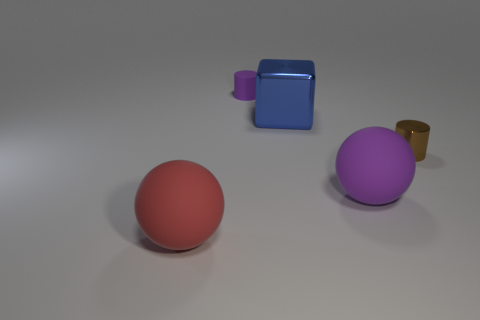Does the small purple rubber object have the same shape as the tiny brown metallic object?
Give a very brief answer. Yes. The matte thing that is both in front of the blue metallic object and to the left of the purple rubber sphere is what color?
Provide a succinct answer. Red. There is a purple thing in front of the tiny brown object; is its size the same as the matte sphere that is to the left of the big cube?
Ensure brevity in your answer.  Yes. How many things are rubber spheres that are on the left side of the purple cylinder or green rubber cylinders?
Give a very brief answer. 1. What material is the purple sphere?
Give a very brief answer. Rubber. Does the red object have the same size as the block?
Provide a succinct answer. Yes. What number of balls are either small brown shiny things or blue metallic things?
Provide a short and direct response. 0. What color is the shiny object on the right side of the matte sphere that is to the right of the block?
Keep it short and to the point. Brown. Are there fewer tiny purple rubber objects in front of the large purple object than big matte objects that are in front of the small brown cylinder?
Your answer should be very brief. Yes. Do the purple sphere and the cylinder right of the blue metal block have the same size?
Keep it short and to the point. No. 